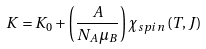<formula> <loc_0><loc_0><loc_500><loc_500>K = K _ { 0 } + \left ( \frac { A } { N _ { A } \mu _ { B } } \right ) \chi _ { s p i n } \left ( T , J \right )</formula> 